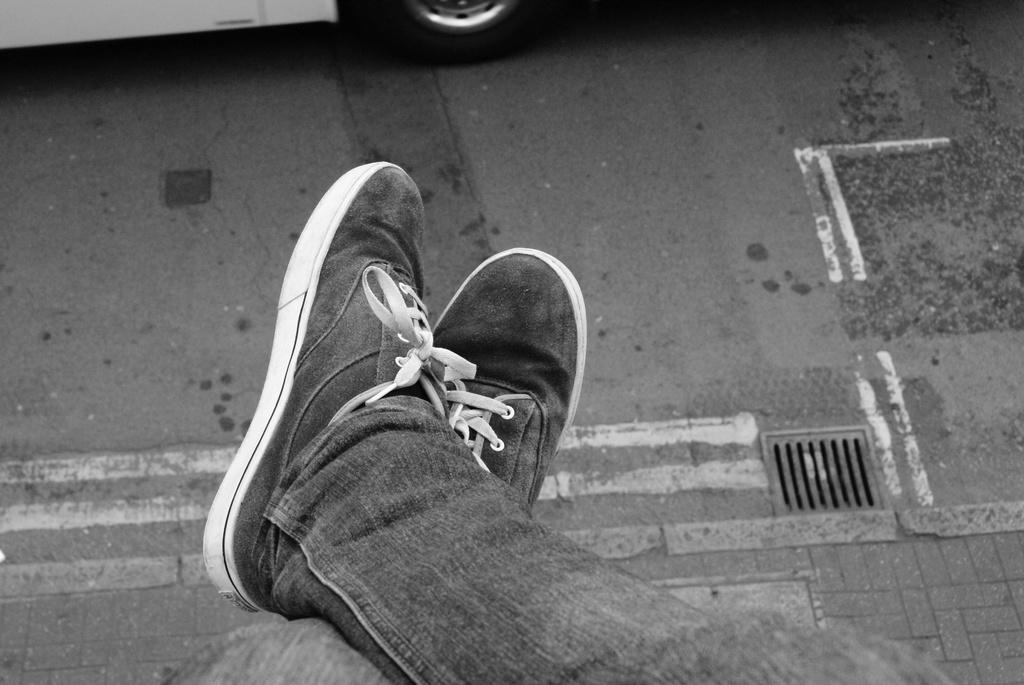What is located in the middle of the picture? There are shoes in the middle of the picture. What type of terrain can be seen in the background of the picture? There is land visible in the background of the picture. What type of agreement is being discussed by the shoes in the picture? There are no people or discussions present in the image, only shoes. The image does not depict any agreements or negotiations. 